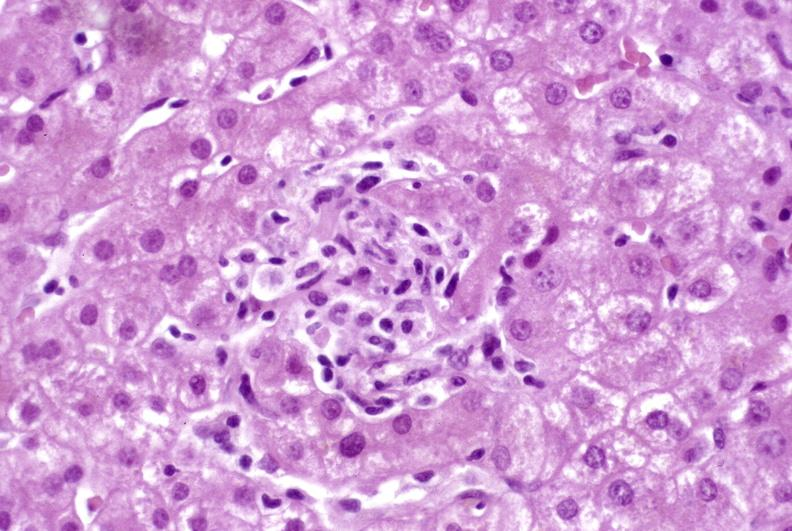s umbilical cord present?
Answer the question using a single word or phrase. No 